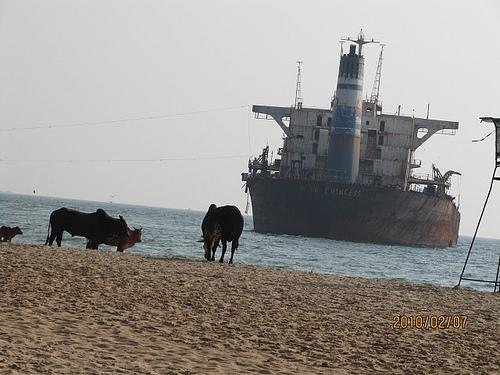What is visible in the water? Please explain your reasoning. boat. It is large and is floating on the water. it is made out of characteristic metal and has a mast at the top for observation. this is typical of this type of vehicle. 